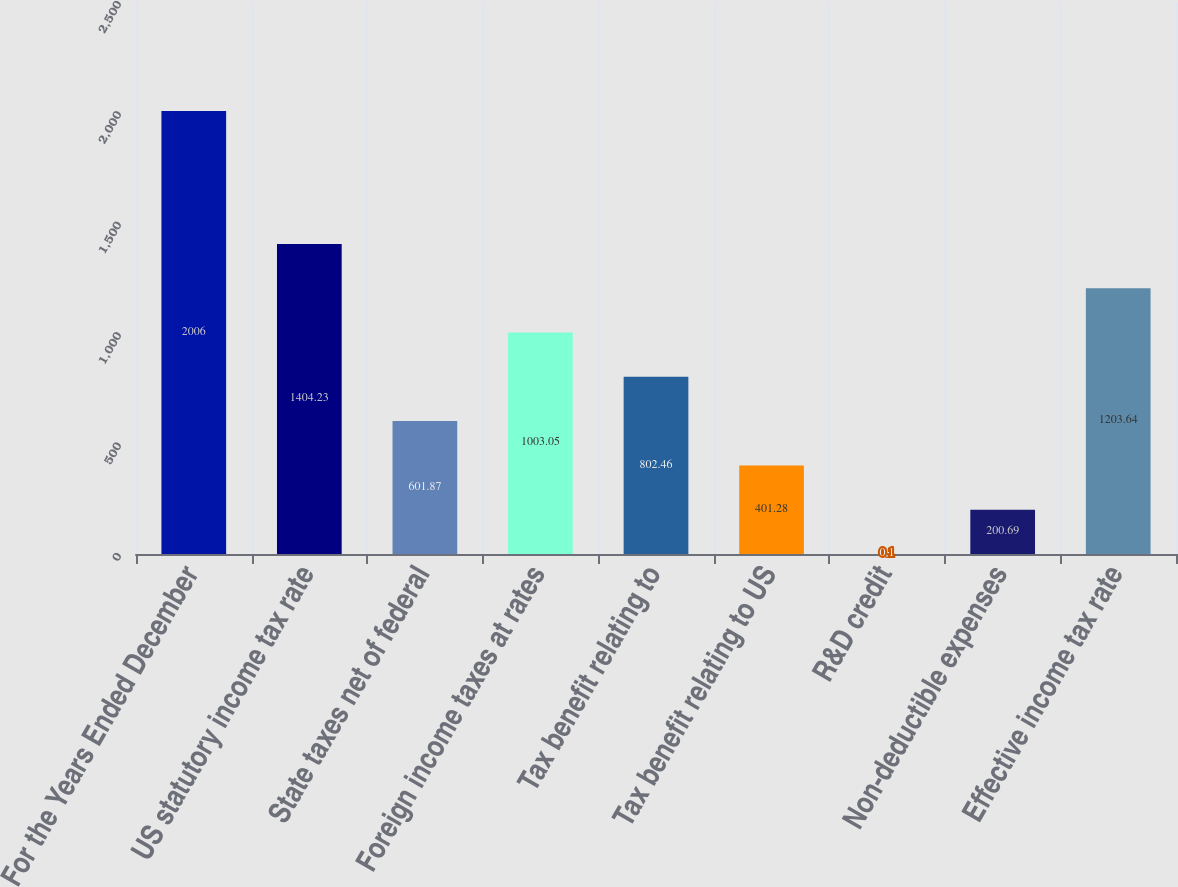Convert chart. <chart><loc_0><loc_0><loc_500><loc_500><bar_chart><fcel>For the Years Ended December<fcel>US statutory income tax rate<fcel>State taxes net of federal<fcel>Foreign income taxes at rates<fcel>Tax benefit relating to<fcel>Tax benefit relating to US<fcel>R&D credit<fcel>Non-deductible expenses<fcel>Effective income tax rate<nl><fcel>2006<fcel>1404.23<fcel>601.87<fcel>1003.05<fcel>802.46<fcel>401.28<fcel>0.1<fcel>200.69<fcel>1203.64<nl></chart> 